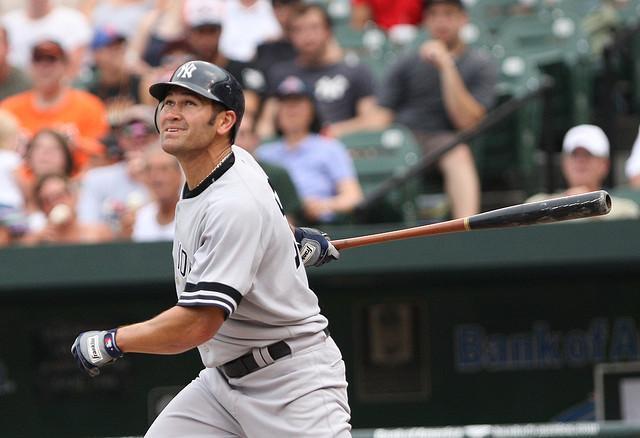How many people are in the picture?
Give a very brief answer. 14. 